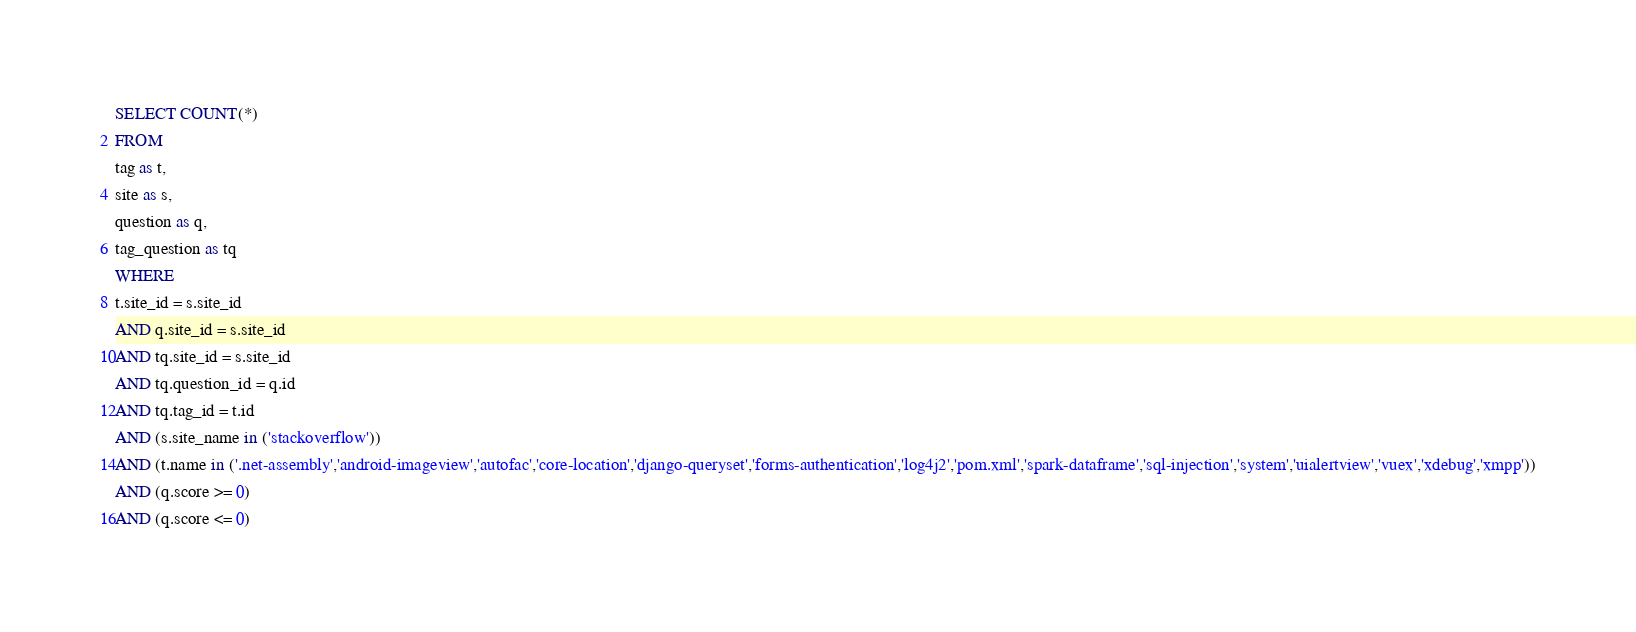<code> <loc_0><loc_0><loc_500><loc_500><_SQL_>SELECT COUNT(*)
FROM
tag as t,
site as s,
question as q,
tag_question as tq
WHERE
t.site_id = s.site_id
AND q.site_id = s.site_id
AND tq.site_id = s.site_id
AND tq.question_id = q.id
AND tq.tag_id = t.id
AND (s.site_name in ('stackoverflow'))
AND (t.name in ('.net-assembly','android-imageview','autofac','core-location','django-queryset','forms-authentication','log4j2','pom.xml','spark-dataframe','sql-injection','system','uialertview','vuex','xdebug','xmpp'))
AND (q.score >= 0)
AND (q.score <= 0)
</code> 